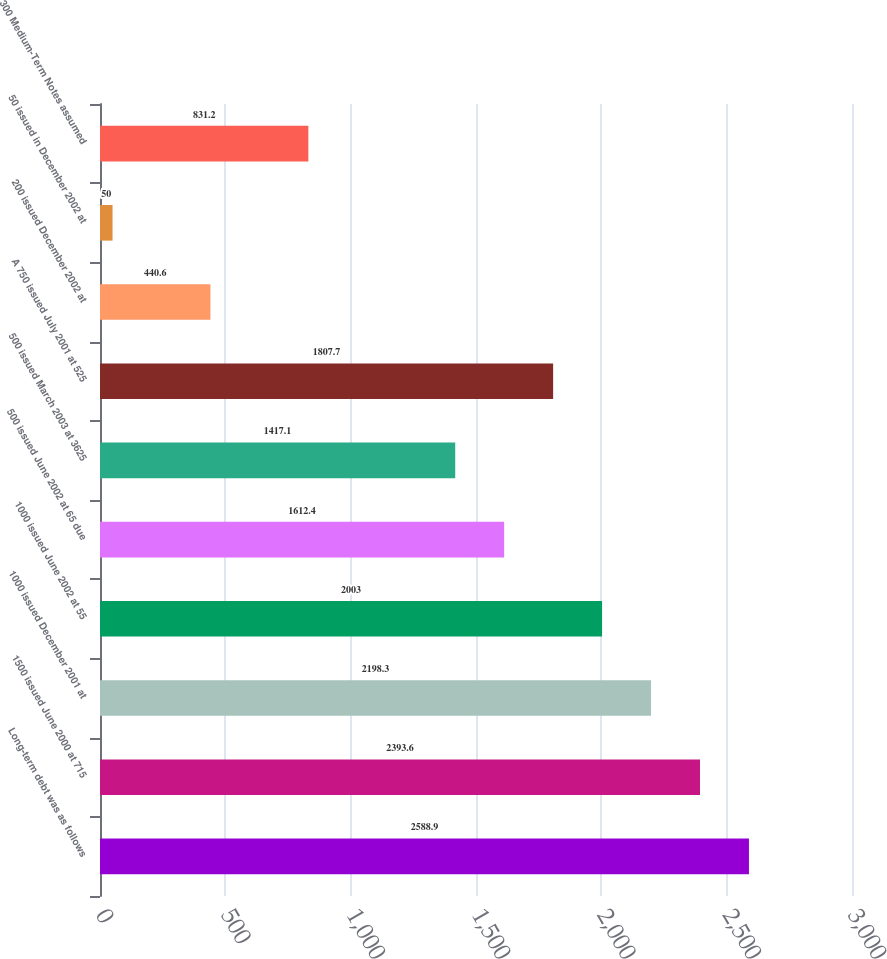Convert chart to OTSL. <chart><loc_0><loc_0><loc_500><loc_500><bar_chart><fcel>Long-term debt was as follows<fcel>1500 issued June 2000 at 715<fcel>1000 issued December 2001 at<fcel>1000 issued June 2002 at 55<fcel>500 issued June 2002 at 65 due<fcel>500 issued March 2003 at 3625<fcel>A 750 issued July 2001 at 525<fcel>200 issued December 2002 at<fcel>50 issued in December 2002 at<fcel>300 Medium-Term Notes assumed<nl><fcel>2588.9<fcel>2393.6<fcel>2198.3<fcel>2003<fcel>1612.4<fcel>1417.1<fcel>1807.7<fcel>440.6<fcel>50<fcel>831.2<nl></chart> 